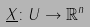<formula> <loc_0><loc_0><loc_500><loc_500>\underline { X } \colon U \rightarrow \mathbb { R } ^ { n }</formula> 